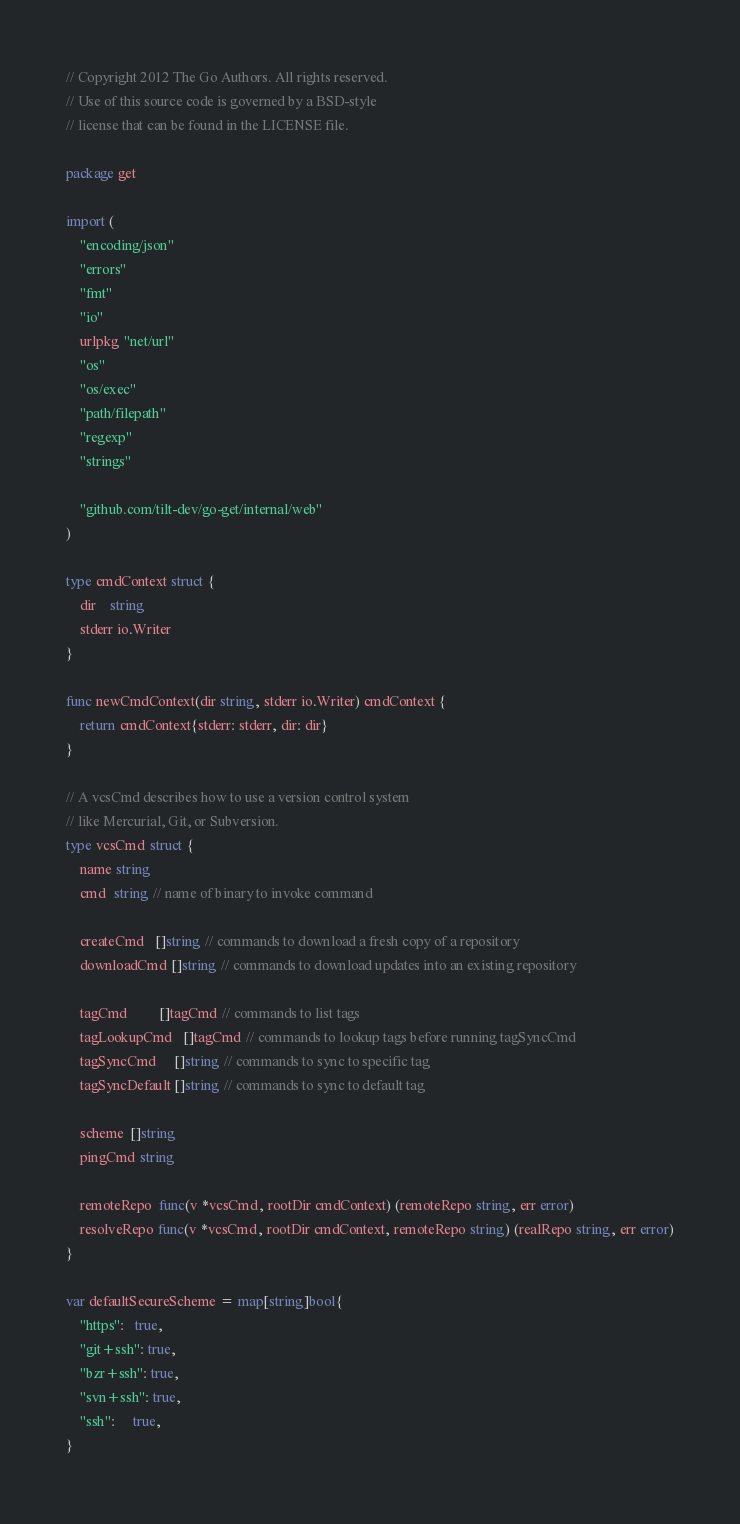<code> <loc_0><loc_0><loc_500><loc_500><_Go_>// Copyright 2012 The Go Authors. All rights reserved.
// Use of this source code is governed by a BSD-style
// license that can be found in the LICENSE file.

package get

import (
	"encoding/json"
	"errors"
	"fmt"
	"io"
	urlpkg "net/url"
	"os"
	"os/exec"
	"path/filepath"
	"regexp"
	"strings"

	"github.com/tilt-dev/go-get/internal/web"
)

type cmdContext struct {
	dir    string
	stderr io.Writer
}

func newCmdContext(dir string, stderr io.Writer) cmdContext {
	return cmdContext{stderr: stderr, dir: dir}
}

// A vcsCmd describes how to use a version control system
// like Mercurial, Git, or Subversion.
type vcsCmd struct {
	name string
	cmd  string // name of binary to invoke command

	createCmd   []string // commands to download a fresh copy of a repository
	downloadCmd []string // commands to download updates into an existing repository

	tagCmd         []tagCmd // commands to list tags
	tagLookupCmd   []tagCmd // commands to lookup tags before running tagSyncCmd
	tagSyncCmd     []string // commands to sync to specific tag
	tagSyncDefault []string // commands to sync to default tag

	scheme  []string
	pingCmd string

	remoteRepo  func(v *vcsCmd, rootDir cmdContext) (remoteRepo string, err error)
	resolveRepo func(v *vcsCmd, rootDir cmdContext, remoteRepo string) (realRepo string, err error)
}

var defaultSecureScheme = map[string]bool{
	"https":   true,
	"git+ssh": true,
	"bzr+ssh": true,
	"svn+ssh": true,
	"ssh":     true,
}
</code> 